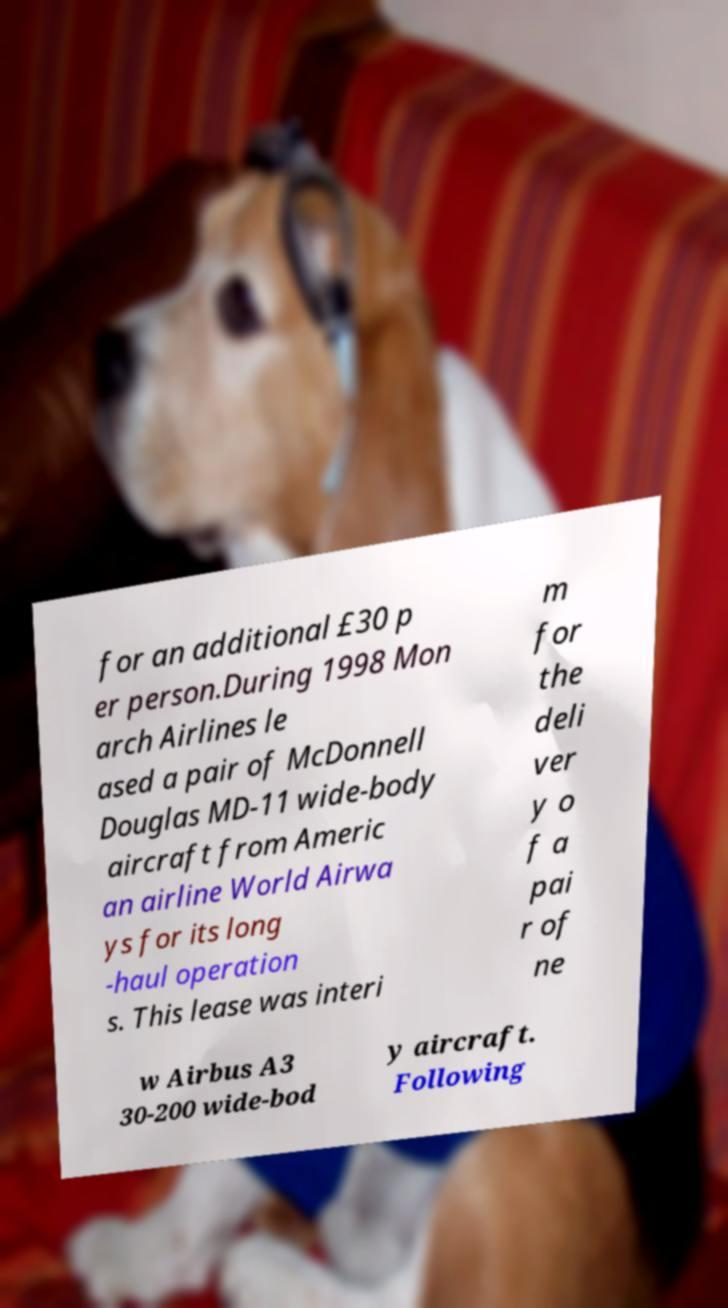Please read and relay the text visible in this image. What does it say? for an additional £30 p er person.During 1998 Mon arch Airlines le ased a pair of McDonnell Douglas MD-11 wide-body aircraft from Americ an airline World Airwa ys for its long -haul operation s. This lease was interi m for the deli ver y o f a pai r of ne w Airbus A3 30-200 wide-bod y aircraft. Following 